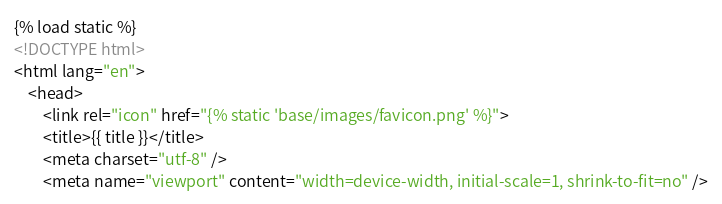Convert code to text. <code><loc_0><loc_0><loc_500><loc_500><_HTML_>{% load static %}
<!DOCTYPE html>
<html lang="en">
    <head>
        <link rel="icon" href="{% static 'base/images/favicon.png' %}">
        <title>{{ title }}</title>
        <meta charset="utf-8" />
        <meta name="viewport" content="width=device-width, initial-scale=1, shrink-to-fit=no" /></code> 